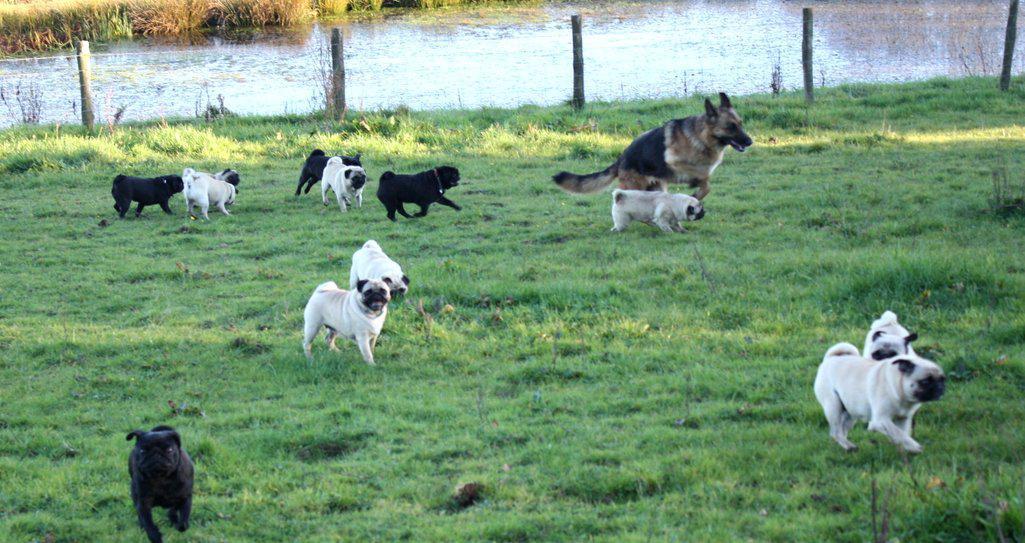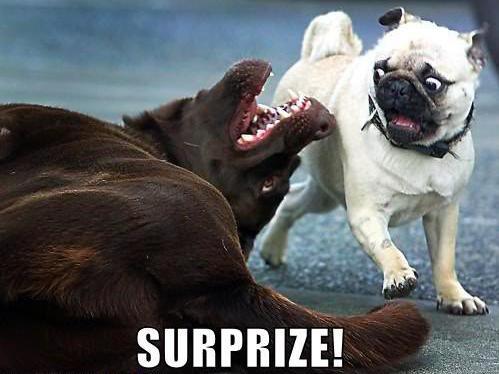The first image is the image on the left, the second image is the image on the right. Given the left and right images, does the statement "An image shows exactly one pug dog, which is facing another living creature that is not a pug." hold true? Answer yes or no. Yes. The first image is the image on the left, the second image is the image on the right. Evaluate the accuracy of this statement regarding the images: "At least one person is with the dogs outside in one of the images.". Is it true? Answer yes or no. No. 